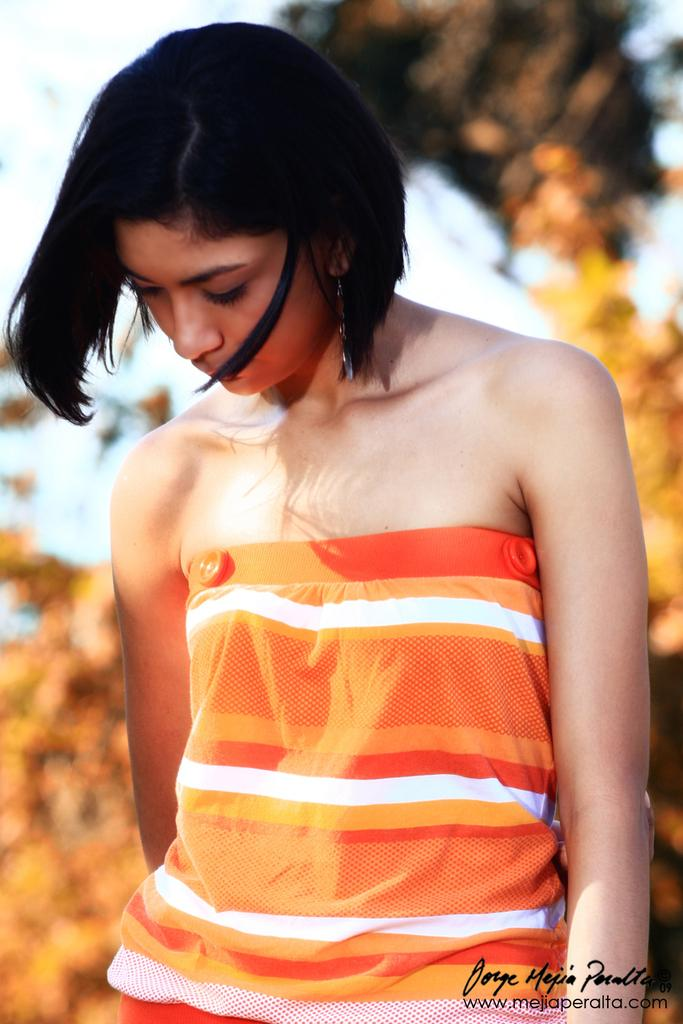What is the main subject of the image? There is a woman standing in the image. Can you describe the background of the image? The background of the image is blurred. Is there any additional information or markings on the image? Yes, there is a watermark on the image. How much wealth does the monkey in the image possess? There is no monkey present in the image, so it is not possible to determine its wealth. 